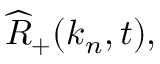<formula> <loc_0><loc_0><loc_500><loc_500>\widehat { R } _ { + } ( k _ { n } , t ) ,</formula> 